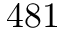<formula> <loc_0><loc_0><loc_500><loc_500>4 8 1</formula> 